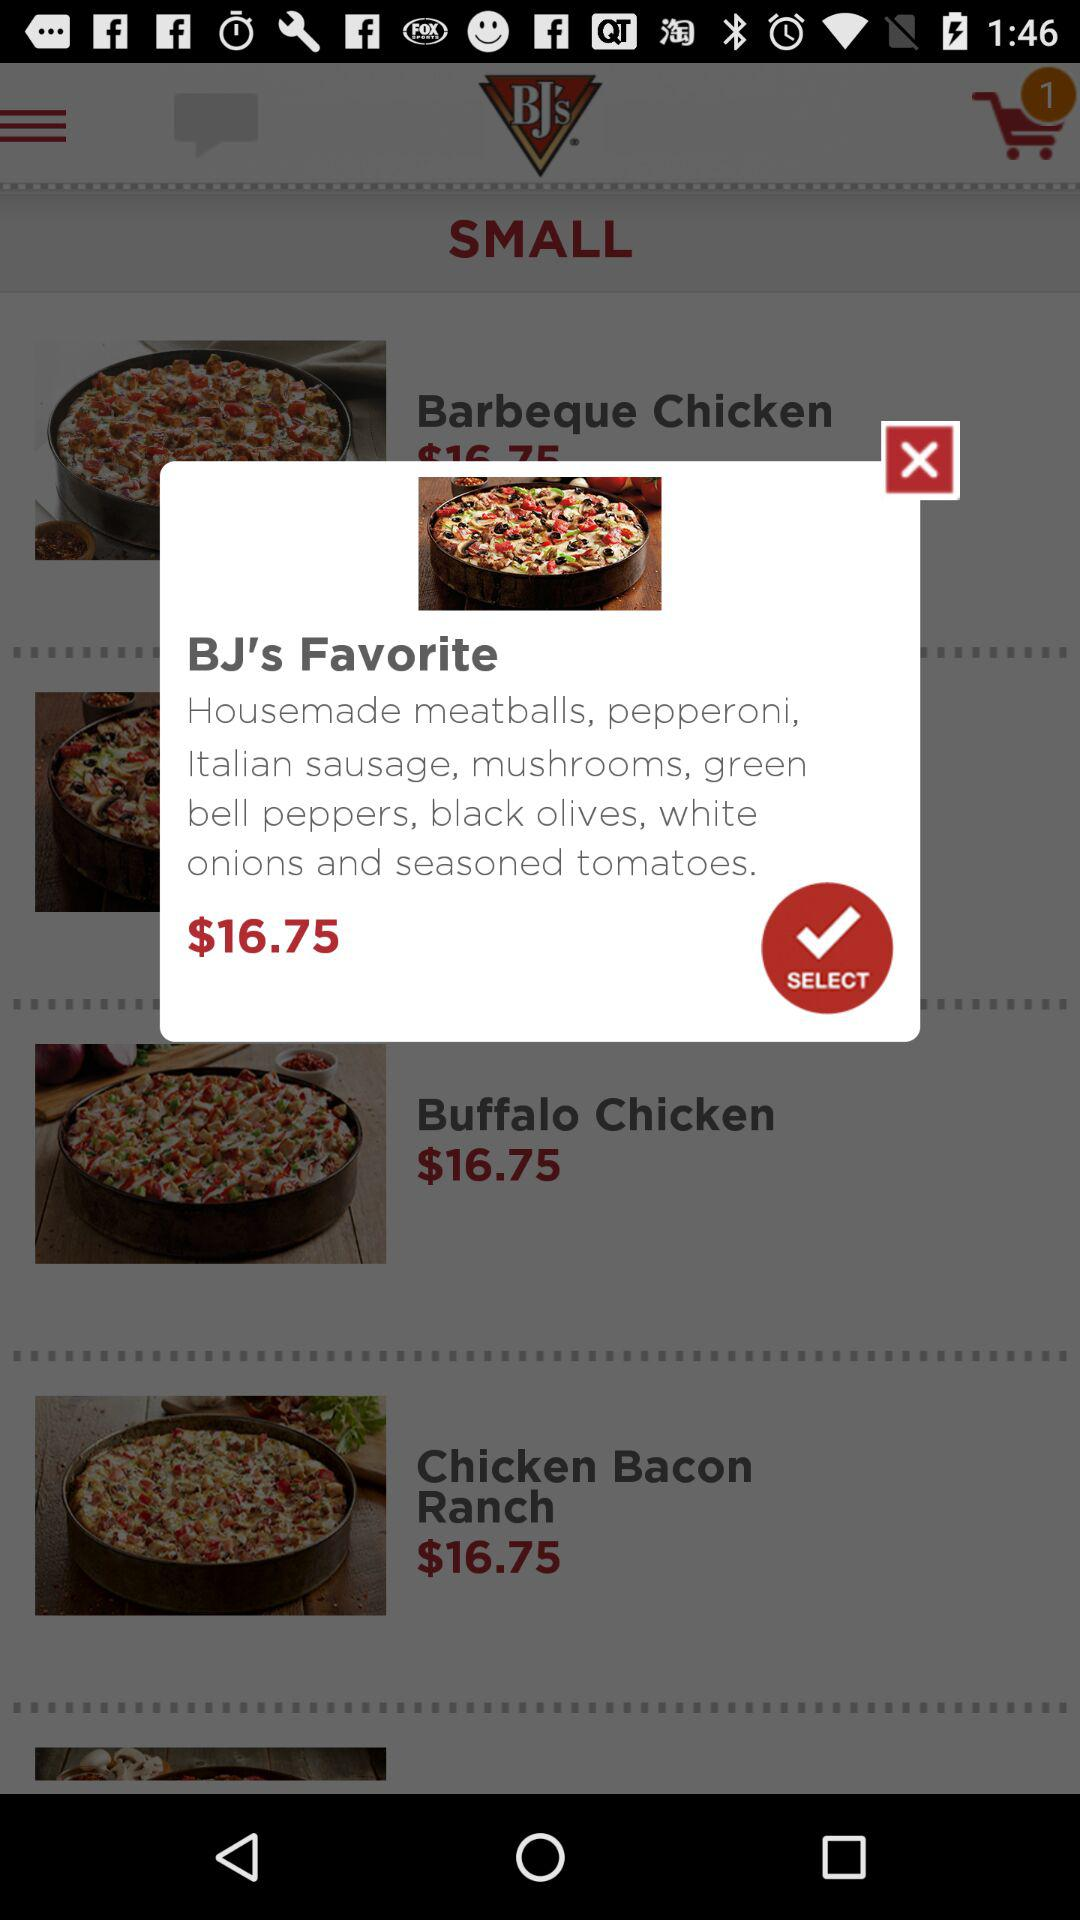What is the price of BJ's Favorite? The price of BJ's Favorite is $16.75. 